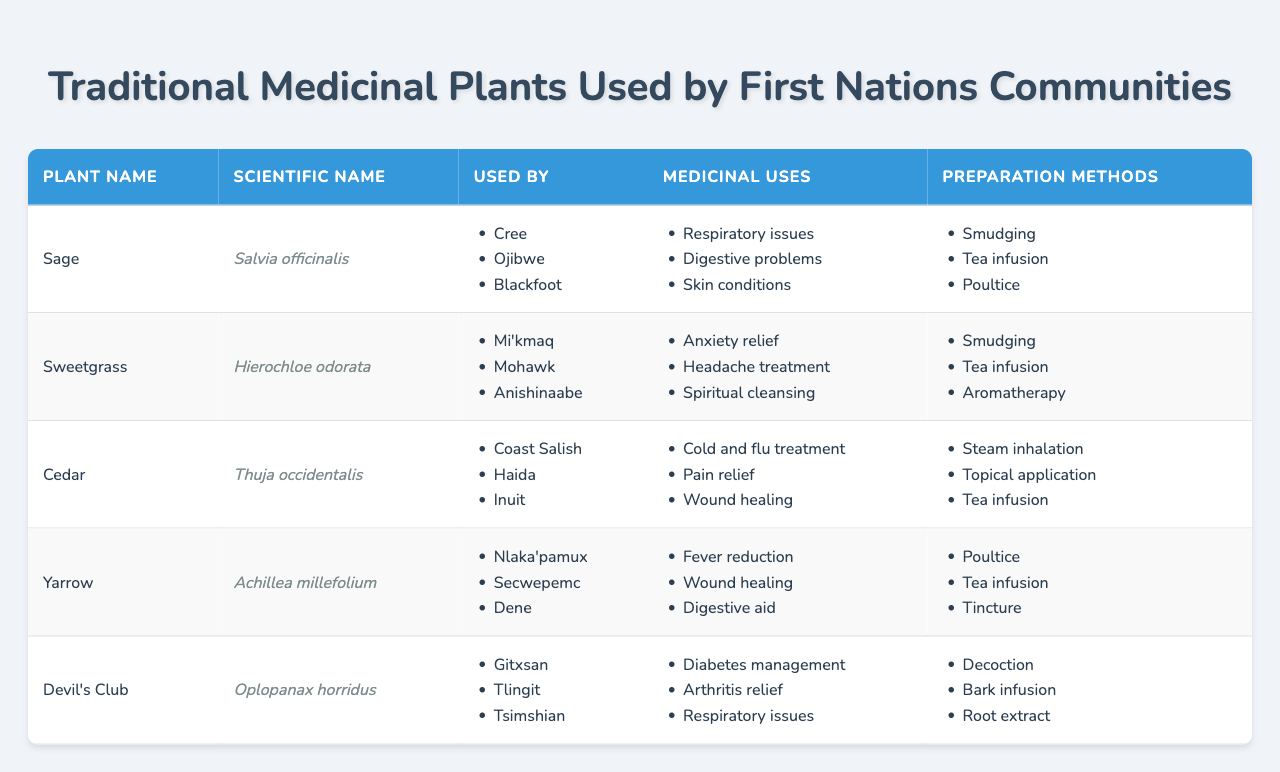What are the medicinal uses of Sage? The medicinal uses of Sage are listed in the table. They include respiratory issues, digestive problems, and skin conditions.
Answer: Respiratory issues, digestive problems, skin conditions Which plant is used by the Cree community? The table indicates that Sage is used by the Cree community.
Answer: Sage How many plants are used by the Coast Salish community? The table shows that Cedar is the only plant listed as used by the Coast Salish community.
Answer: 1 Is Sweetgrass used for anxiety relief? According to the table, anxiety relief is one of the medicinal uses listed for Sweetgrass.
Answer: Yes Which plant has the scientific name 'Oplopanax horridus'? Looking at the scientific names in the table, Devil's Club corresponds to 'Oplopanax horridus'.
Answer: Devil's Club How many medicinal uses does Yarrow have, and what are they? The table lists three medicinal uses for Yarrow: fever reduction, wound healing, and digestive aid. Thus, Yarrow has three medicinal uses.
Answer: Three: fever reduction, wound healing, digestive aid Do the communities using Devil's Club include the Gitxsan? The table shows that Devil's Club is indeed used by the Gitxsan community.
Answer: Yes Which plant is used by both the Mohawk and Anishinaabe communities? The table lists Sweetgrass as used by both the Mohawk and Anishinaabe communities.
Answer: Sweetgrass If we combine the medicinal uses for Cedar and Sage, what are they? Cedar is used for cold and flu treatment, pain relief, and wound healing; Sage is used for respiratory issues, digestive problems, and skin conditions. Together, they have six distinct medicinal uses: cold and flu treatment, pain relief, wound healing, respiratory issues, digestive problems, and skin conditions.
Answer: Cold and flu treatment, pain relief, wound healing, respiratory issues, digestive problems, skin conditions Which preparation method is common for both Sage and Sweetgrass? The table indicates that Smudging is a preparation method used for both Sage and Sweetgrass.
Answer: Smudging What is the total number of preparation methods listed for Devil's Club? The table shows that Devil's Club has three preparation methods: decoction, bark infusion, and root extract. Therefore, the total is three.
Answer: Three 